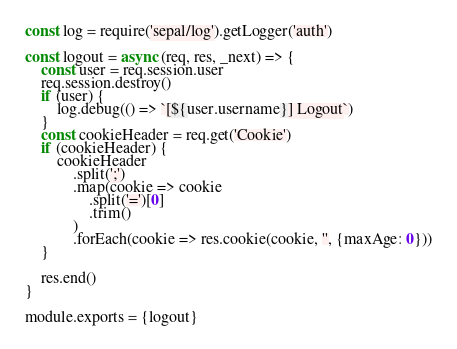<code> <loc_0><loc_0><loc_500><loc_500><_JavaScript_>const log = require('sepal/log').getLogger('auth')

const logout = async (req, res, _next) => {
    const user = req.session.user
    req.session.destroy()
    if (user) {
        log.debug(() => `[${user.username}] Logout`)
    }
    const cookieHeader = req.get('Cookie')
    if (cookieHeader) {
        cookieHeader
            .split(';')
            .map(cookie => cookie
                .split('=')[0]
                .trim()
            )
            .forEach(cookie => res.cookie(cookie, '', {maxAge: 0}))
    }

    res.end()
}

module.exports = {logout}
</code> 